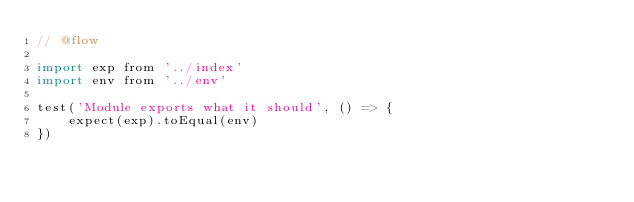<code> <loc_0><loc_0><loc_500><loc_500><_JavaScript_>// @flow

import exp from '../index'
import env from '../env'

test('Module exports what it should', () => {
    expect(exp).toEqual(env)
})
</code> 